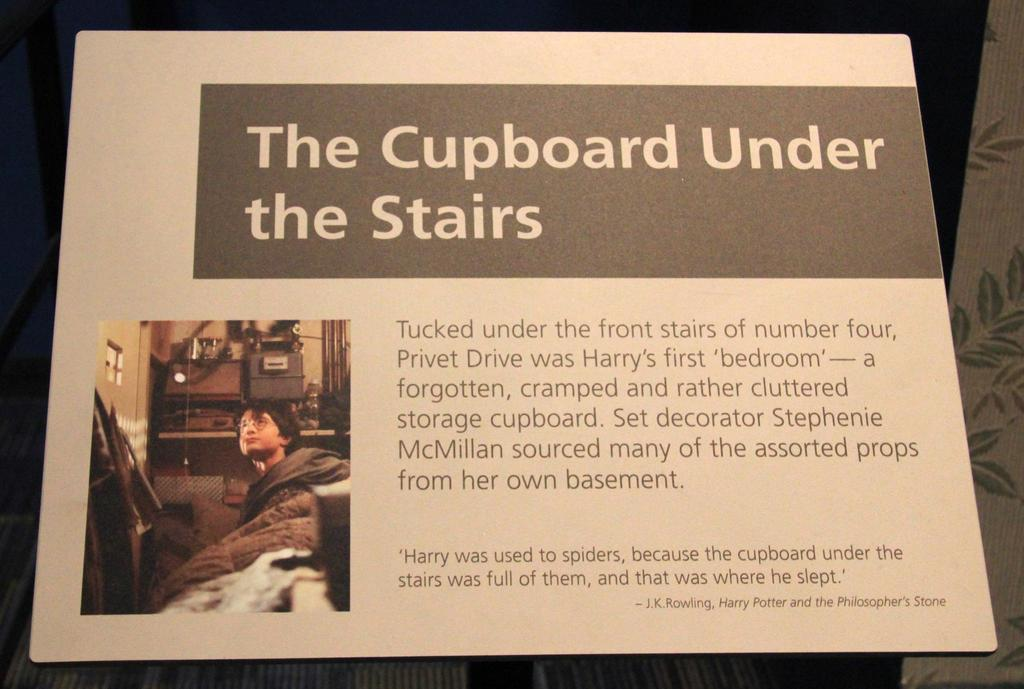<image>
Describe the image concisely. An article titled The Cupboard Under the stairs talks about the first bedroom a boy named Harry had. 